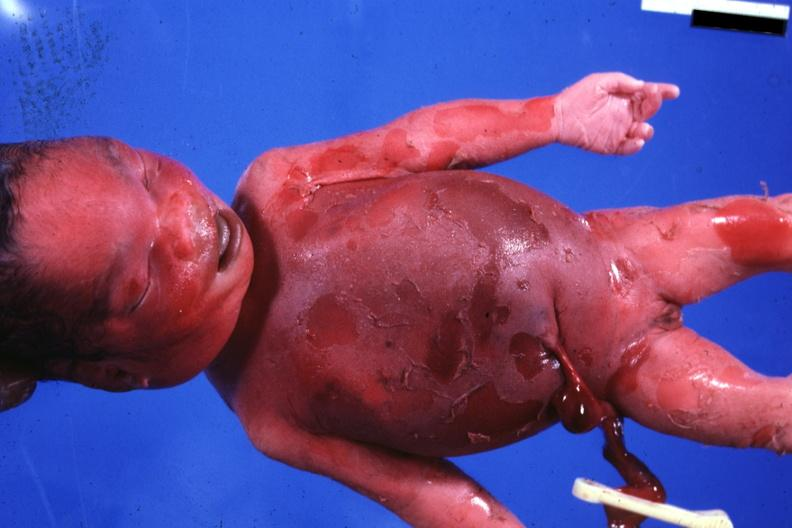what does this image show?
Answer the question using a single word or phrase. Typical appearance 980gm 